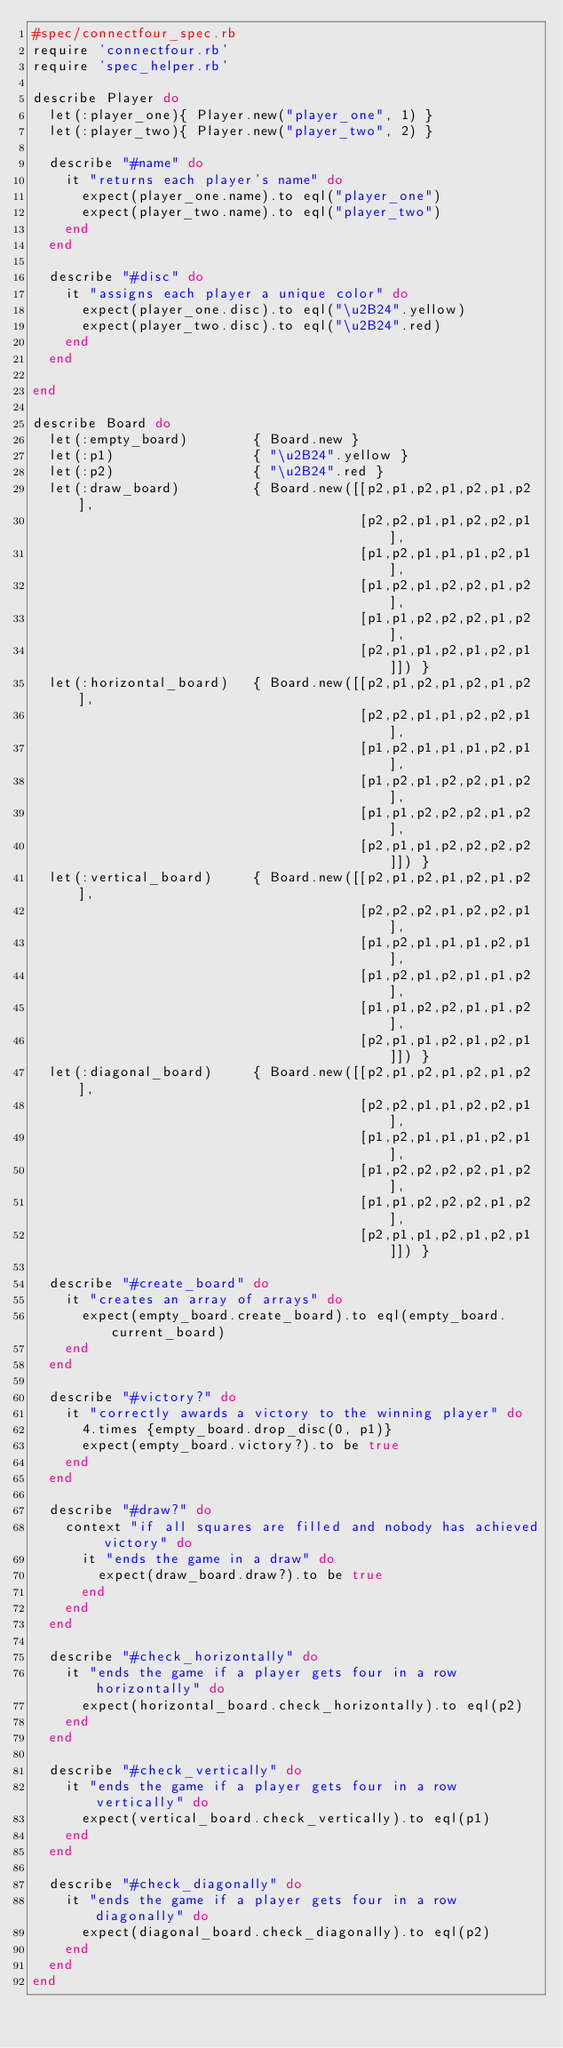Convert code to text. <code><loc_0><loc_0><loc_500><loc_500><_Ruby_>#spec/connectfour_spec.rb
require 'connectfour.rb'
require 'spec_helper.rb'

describe Player do
  let(:player_one){ Player.new("player_one", 1) }
  let(:player_two){ Player.new("player_two", 2) }
  
  describe "#name" do
    it "returns each player's name" do
      expect(player_one.name).to eql("player_one")
      expect(player_two.name).to eql("player_two")
    end
  end
  
  describe "#disc" do
    it "assigns each player a unique color" do
      expect(player_one.disc).to eql("\u2B24".yellow)
      expect(player_two.disc).to eql("\u2B24".red)
    end
  end
  
end

describe Board do
  let(:empty_board)        { Board.new }
  let(:p1)                 { "\u2B24".yellow }
  let(:p2)                 { "\u2B24".red }
  let(:draw_board)         { Board.new([[p2,p1,p2,p1,p2,p1,p2],
                                        [p2,p2,p1,p1,p2,p2,p1],
                                        [p1,p2,p1,p1,p1,p2,p1],
                                        [p1,p2,p1,p2,p2,p1,p2],
                                        [p1,p1,p2,p2,p2,p1,p2],
                                        [p2,p1,p1,p2,p1,p2,p1]]) }
  let(:horizontal_board)   { Board.new([[p2,p1,p2,p1,p2,p1,p2],
                                        [p2,p2,p1,p1,p2,p2,p1],
                                        [p1,p2,p1,p1,p1,p2,p1],
                                        [p1,p2,p1,p2,p2,p1,p2],
                                        [p1,p1,p2,p2,p2,p1,p2],
                                        [p2,p1,p1,p2,p2,p2,p2]]) }
  let(:vertical_board)     { Board.new([[p2,p1,p2,p1,p2,p1,p2],
                                        [p2,p2,p2,p1,p2,p2,p1],
                                        [p1,p2,p1,p1,p1,p2,p1],
                                        [p1,p2,p1,p2,p1,p1,p2],
                                        [p1,p1,p2,p2,p1,p1,p2],
                                        [p2,p1,p1,p2,p1,p2,p1]]) }
  let(:diagonal_board)     { Board.new([[p2,p1,p2,p1,p2,p1,p2],
                                        [p2,p2,p1,p1,p2,p2,p1],
                                        [p1,p2,p1,p1,p1,p2,p1],
                                        [p1,p2,p2,p2,p2,p1,p2],
                                        [p1,p1,p2,p2,p2,p1,p2],
                                        [p2,p1,p1,p2,p1,p2,p1]]) }
  
  describe "#create_board" do
    it "creates an array of arrays" do
      expect(empty_board.create_board).to eql(empty_board.current_board)
    end
  end
  
  describe "#victory?" do
    it "correctly awards a victory to the winning player" do
      4.times {empty_board.drop_disc(0, p1)}
      expect(empty_board.victory?).to be true
    end
  end
  
  describe "#draw?" do
    context "if all squares are filled and nobody has achieved victory" do
      it "ends the game in a draw" do      
        expect(draw_board.draw?).to be true
      end
    end
  end    
  
  describe "#check_horizontally" do
    it "ends the game if a player gets four in a row horizontally" do
      expect(horizontal_board.check_horizontally).to eql(p2)
    end
  end
  
  describe "#check_vertically" do
    it "ends the game if a player gets four in a row vertically" do
      expect(vertical_board.check_vertically).to eql(p1)
    end
  end
  
  describe "#check_diagonally" do
    it "ends the game if a player gets four in a row diagonally" do
      expect(diagonal_board.check_diagonally).to eql(p2)
    end
  end  
end</code> 